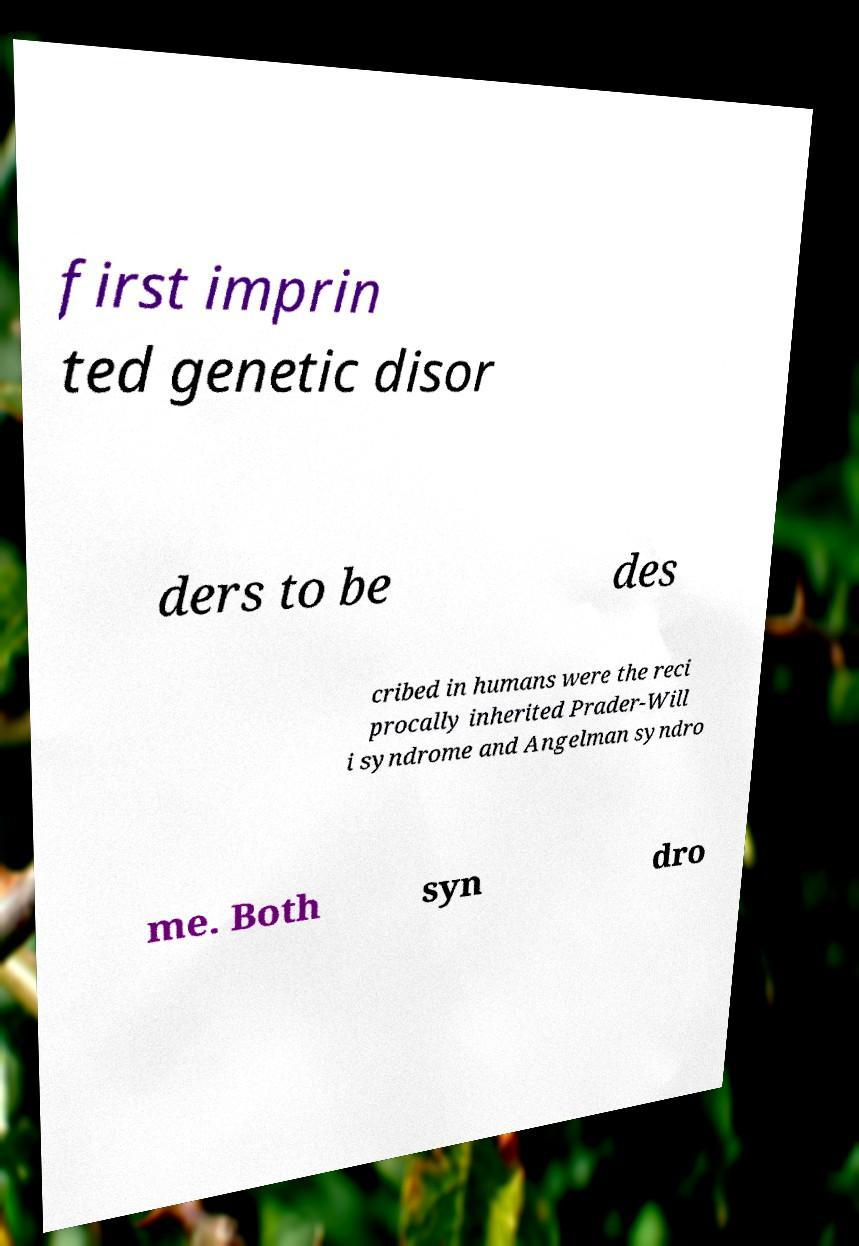What messages or text are displayed in this image? I need them in a readable, typed format. first imprin ted genetic disor ders to be des cribed in humans were the reci procally inherited Prader-Will i syndrome and Angelman syndro me. Both syn dro 